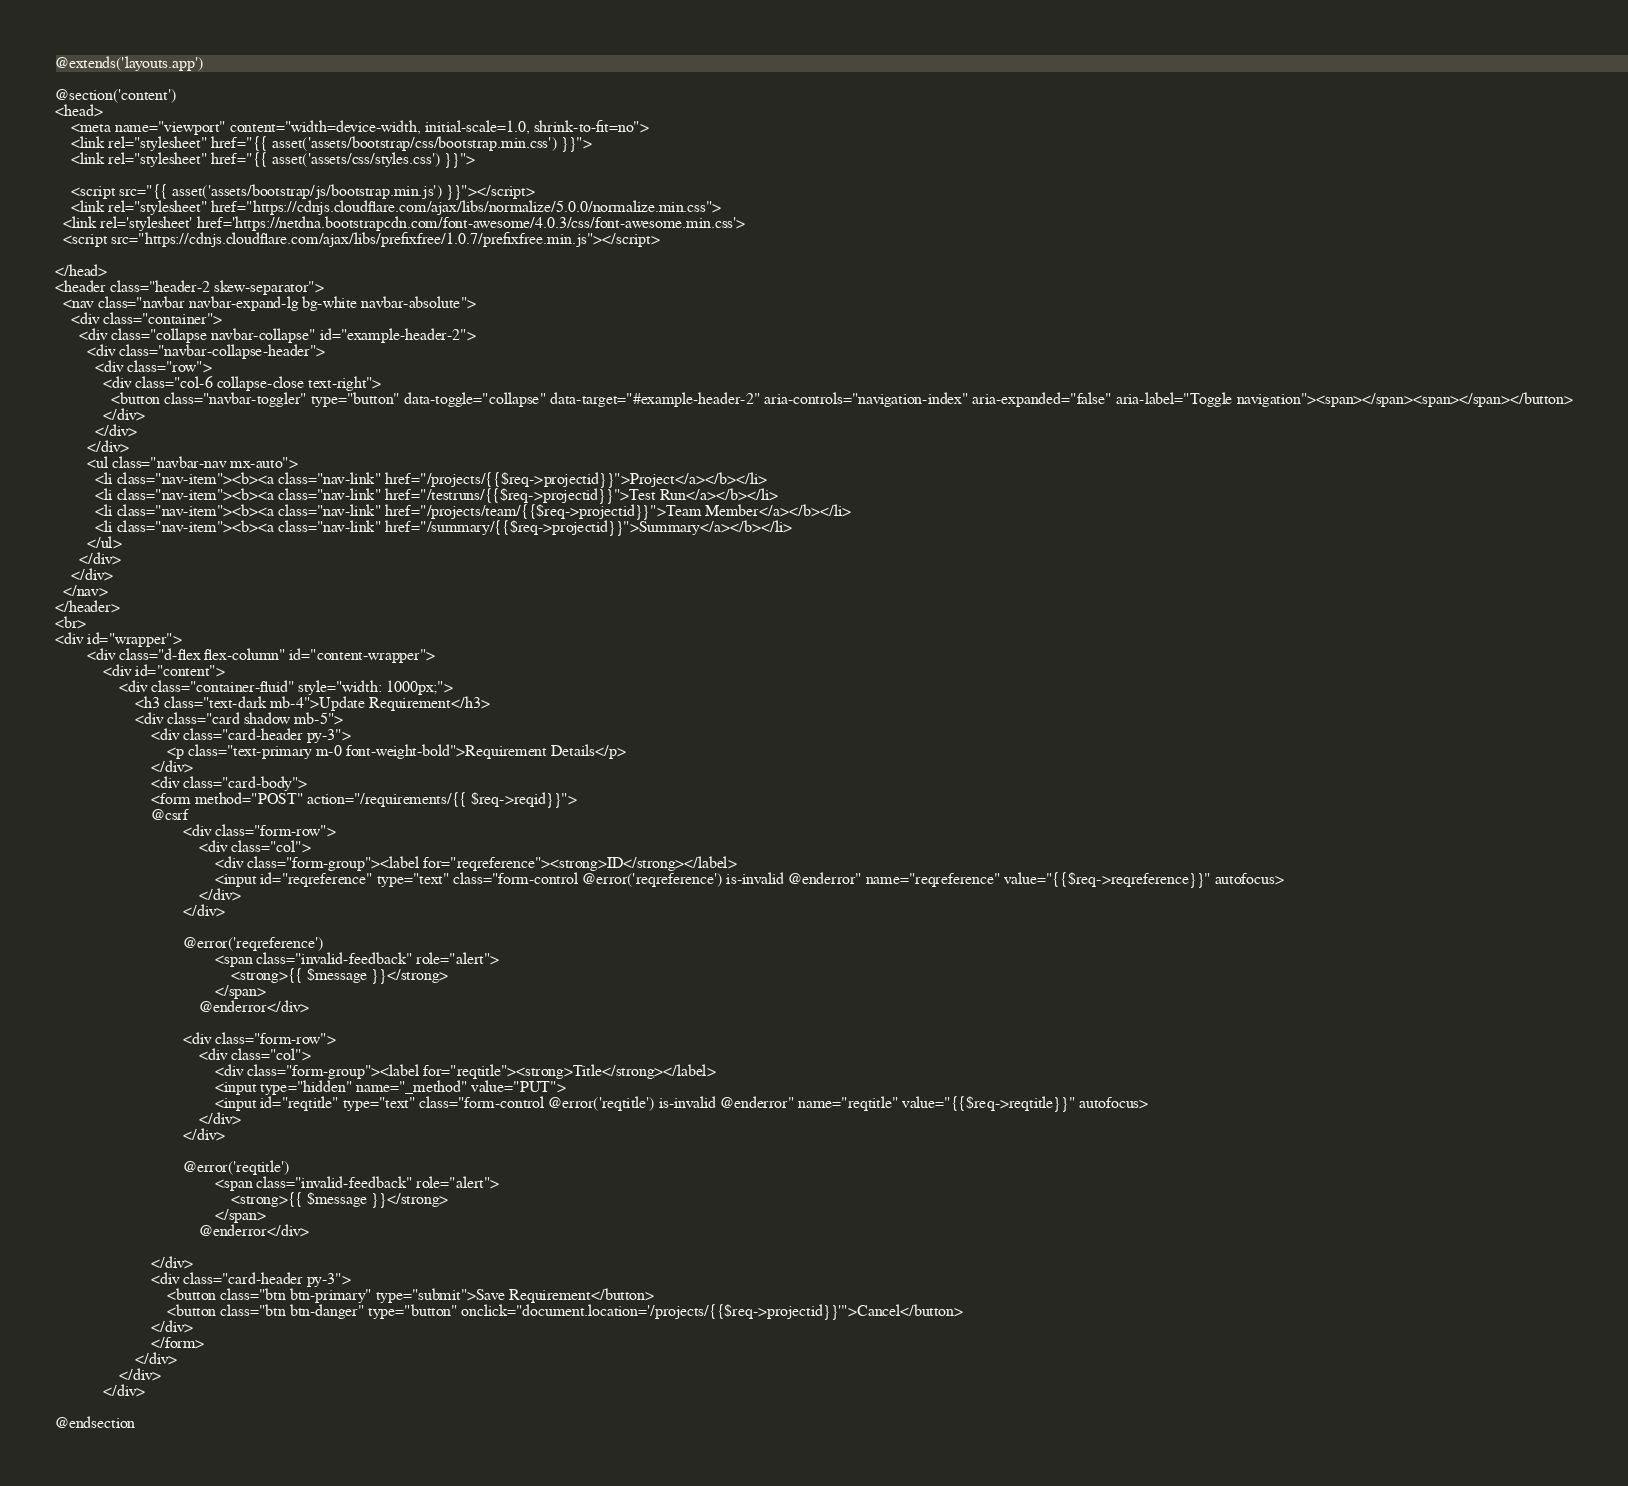<code> <loc_0><loc_0><loc_500><loc_500><_PHP_>@extends('layouts.app')

@section('content')
<head>
    <meta name="viewport" content="width=device-width, initial-scale=1.0, shrink-to-fit=no">
    <link rel="stylesheet" href="{{ asset('assets/bootstrap/css/bootstrap.min.css') }}">
    <link rel="stylesheet" href="{{ asset('assets/css/styles.css') }}">
    
    <script src="{{ asset('assets/bootstrap/js/bootstrap.min.js') }}"></script>
    <link rel="stylesheet" href="https://cdnjs.cloudflare.com/ajax/libs/normalize/5.0.0/normalize.min.css">
  <link rel='stylesheet' href='https://netdna.bootstrapcdn.com/font-awesome/4.0.3/css/font-awesome.min.css'>
  <script src="https://cdnjs.cloudflare.com/ajax/libs/prefixfree/1.0.7/prefixfree.min.js"></script>
    
</head>
<header class="header-2 skew-separator">
  <nav class="navbar navbar-expand-lg bg-white navbar-absolute">
    <div class="container">
      <div class="collapse navbar-collapse" id="example-header-2">
        <div class="navbar-collapse-header">
          <div class="row">
            <div class="col-6 collapse-close text-right">
              <button class="navbar-toggler" type="button" data-toggle="collapse" data-target="#example-header-2" aria-controls="navigation-index" aria-expanded="false" aria-label="Toggle navigation"><span></span><span></span></button>
            </div>
          </div>
        </div>
        <ul class="navbar-nav mx-auto">
          <li class="nav-item"><b><a class="nav-link" href="/projects/{{$req->projectid}}">Project</a></b></li>
          <li class="nav-item"><b><a class="nav-link" href="/testruns/{{$req->projectid}}">Test Run</a></b></li>
          <li class="nav-item"><b><a class="nav-link" href="/projects/team/{{$req->projectid}}">Team Member</a></b></li>
          <li class="nav-item"><b><a class="nav-link" href="/summary/{{$req->projectid}}">Summary</a></b></li>
        </ul>
      </div>
    </div>
  </nav>
</header>
<br>
<div id="wrapper">
        <div class="d-flex flex-column" id="content-wrapper">
            <div id="content">
                <div class="container-fluid" style="width: 1000px;">
                    <h3 class="text-dark mb-4">Update Requirement</h3>
                    <div class="card shadow mb-5">
                        <div class="card-header py-3">
                            <p class="text-primary m-0 font-weight-bold">Requirement Details</p>
                        </div>
                        <div class="card-body">
                        <form method="POST" action="/requirements/{{ $req->reqid}}">
                        @csrf
                                <div class="form-row">
                                    <div class="col">
                                        <div class="form-group"><label for="reqreference"><strong>ID</strong></label>
                                        <input id="reqreference" type="text" class="form-control @error('reqreference') is-invalid @enderror" name="reqreference" value="{{$req->reqreference}}" autofocus>
                                    </div>
                                </div>

                                @error('reqreference')
                                        <span class="invalid-feedback" role="alert">
                                            <strong>{{ $message }}</strong>
                                        </span>
                                    @enderror</div>

                                <div class="form-row">
                                    <div class="col">
                                        <div class="form-group"><label for="reqtitle"><strong>Title</strong></label>
                                        <input type="hidden" name="_method" value="PUT">
                                        <input id="reqtitle" type="text" class="form-control @error('reqtitle') is-invalid @enderror" name="reqtitle" value="{{$req->reqtitle}}" autofocus>
                                    </div>
                                </div>

                                @error('reqtitle')
                                        <span class="invalid-feedback" role="alert">
                                            <strong>{{ $message }}</strong>
                                        </span>
                                    @enderror</div>
                        
                        </div>
                        <div class="card-header py-3">
                            <button class="btn btn-primary" type="submit">Save Requirement</button>
                            <button class="btn btn-danger" type="button" onclick="document.location='/projects/{{$req->projectid}}'">Cancel</button>
                        </div>
                        </form>
                    </div>
                </div>
            </div>

@endsection

</code> 